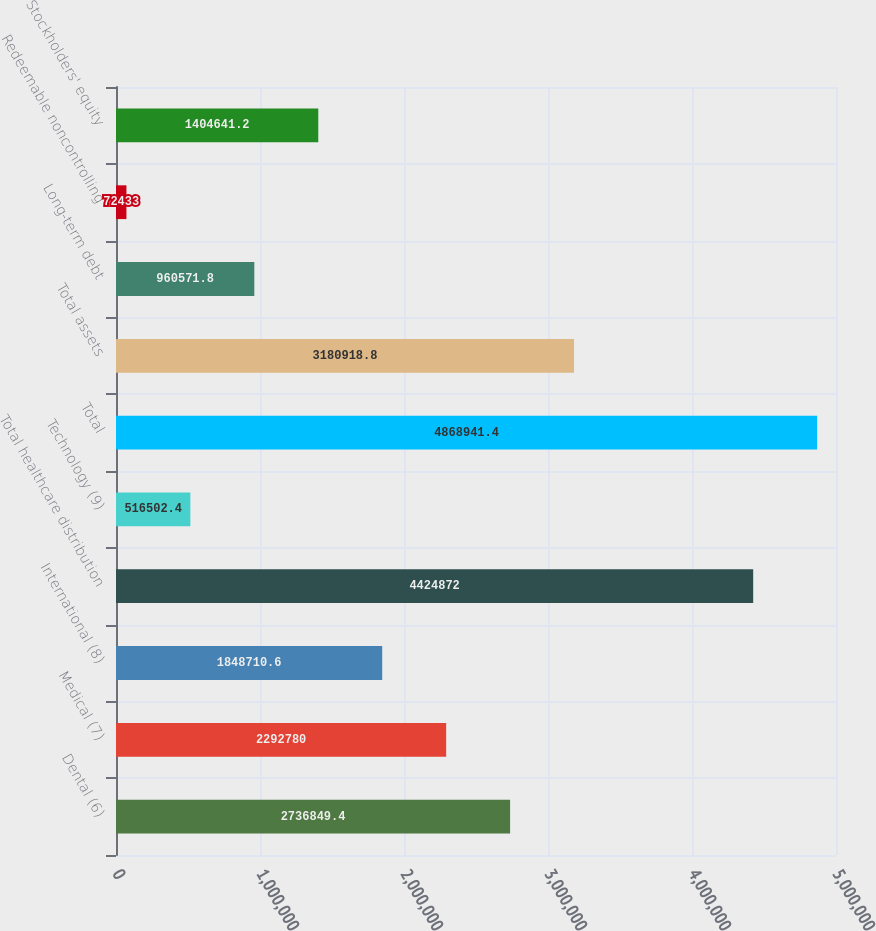<chart> <loc_0><loc_0><loc_500><loc_500><bar_chart><fcel>Dental (6)<fcel>Medical (7)<fcel>International (8)<fcel>Total healthcare distribution<fcel>Technology (9)<fcel>Total<fcel>Total assets<fcel>Long-term debt<fcel>Redeemable noncontrolling<fcel>Stockholders' equity<nl><fcel>2.73685e+06<fcel>2.29278e+06<fcel>1.84871e+06<fcel>4.42487e+06<fcel>516502<fcel>4.86894e+06<fcel>3.18092e+06<fcel>960572<fcel>72433<fcel>1.40464e+06<nl></chart> 